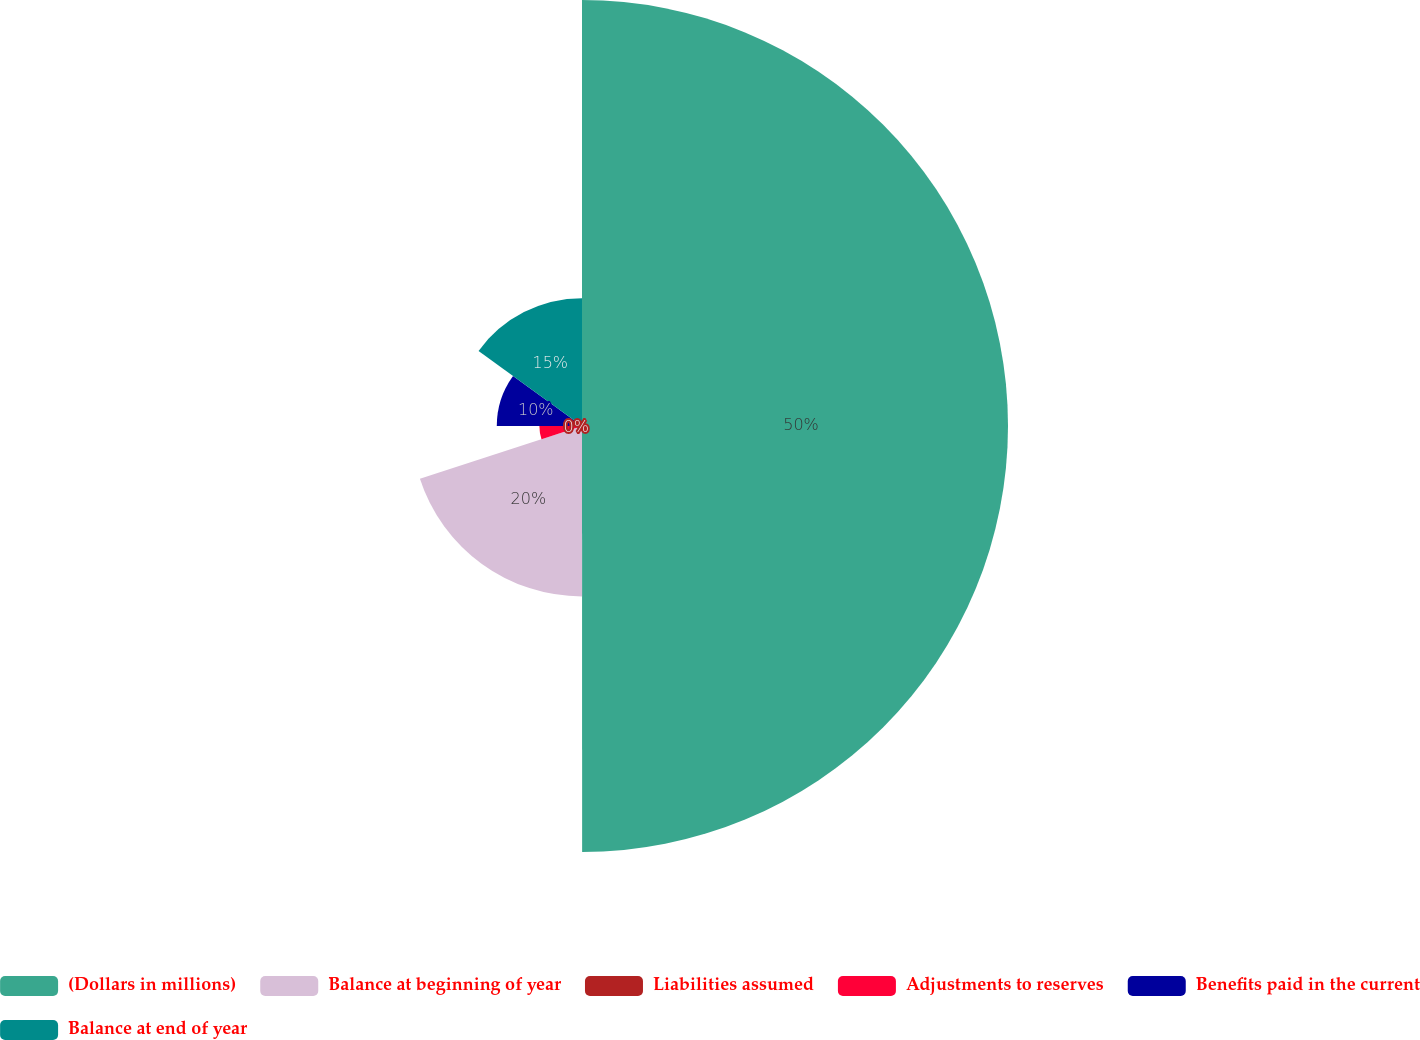Convert chart to OTSL. <chart><loc_0><loc_0><loc_500><loc_500><pie_chart><fcel>(Dollars in millions)<fcel>Balance at beginning of year<fcel>Liabilities assumed<fcel>Adjustments to reserves<fcel>Benefits paid in the current<fcel>Balance at end of year<nl><fcel>49.99%<fcel>20.0%<fcel>0.0%<fcel>5.0%<fcel>10.0%<fcel>15.0%<nl></chart> 